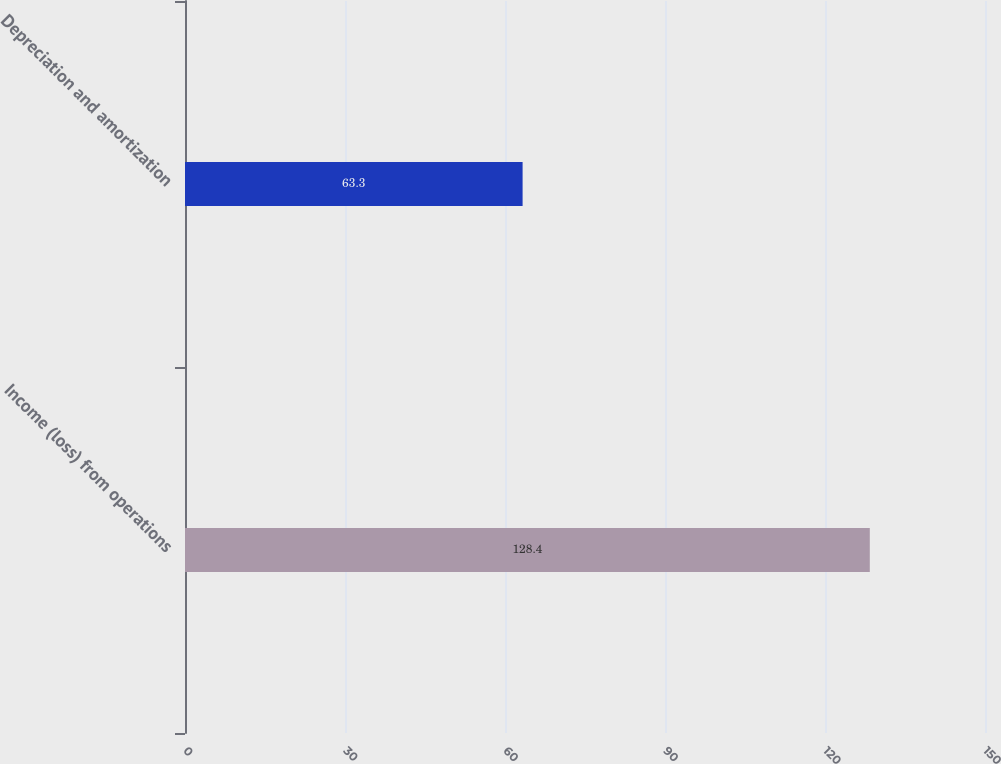Convert chart to OTSL. <chart><loc_0><loc_0><loc_500><loc_500><bar_chart><fcel>Income (loss) from operations<fcel>Depreciation and amortization<nl><fcel>128.4<fcel>63.3<nl></chart> 